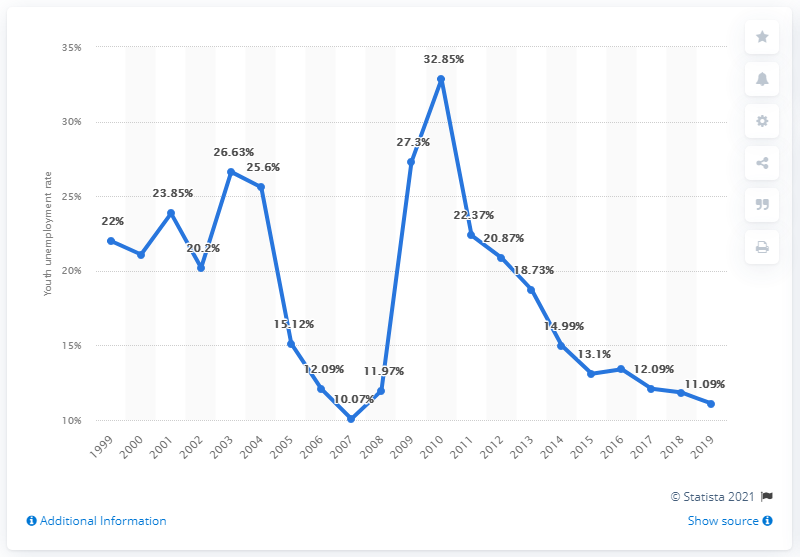Draw attention to some important aspects in this diagram. In 2019, the youth unemployment rate in Estonia was 11.09%. 